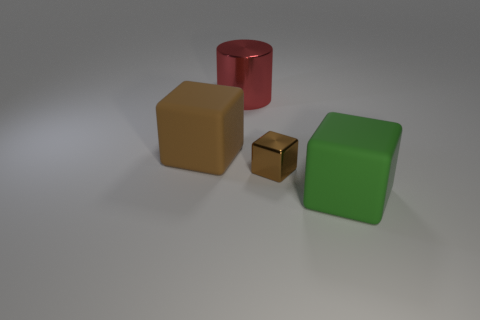Add 3 big green objects. How many objects exist? 7 Subtract all blocks. How many objects are left? 1 Subtract 1 green cubes. How many objects are left? 3 Subtract all big green cubes. Subtract all tiny red metallic cylinders. How many objects are left? 3 Add 3 brown blocks. How many brown blocks are left? 5 Add 2 purple shiny spheres. How many purple shiny spheres exist? 2 